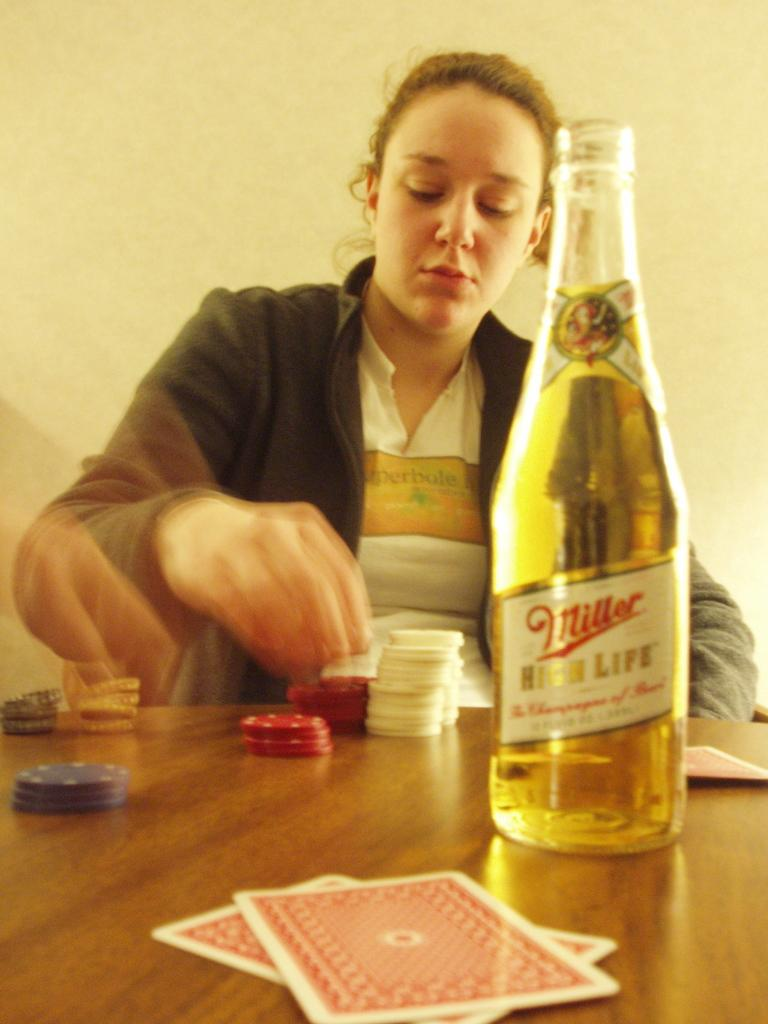Provide a one-sentence caption for the provided image. The woman is playing with the poker chips and drinking Miller High Life. 